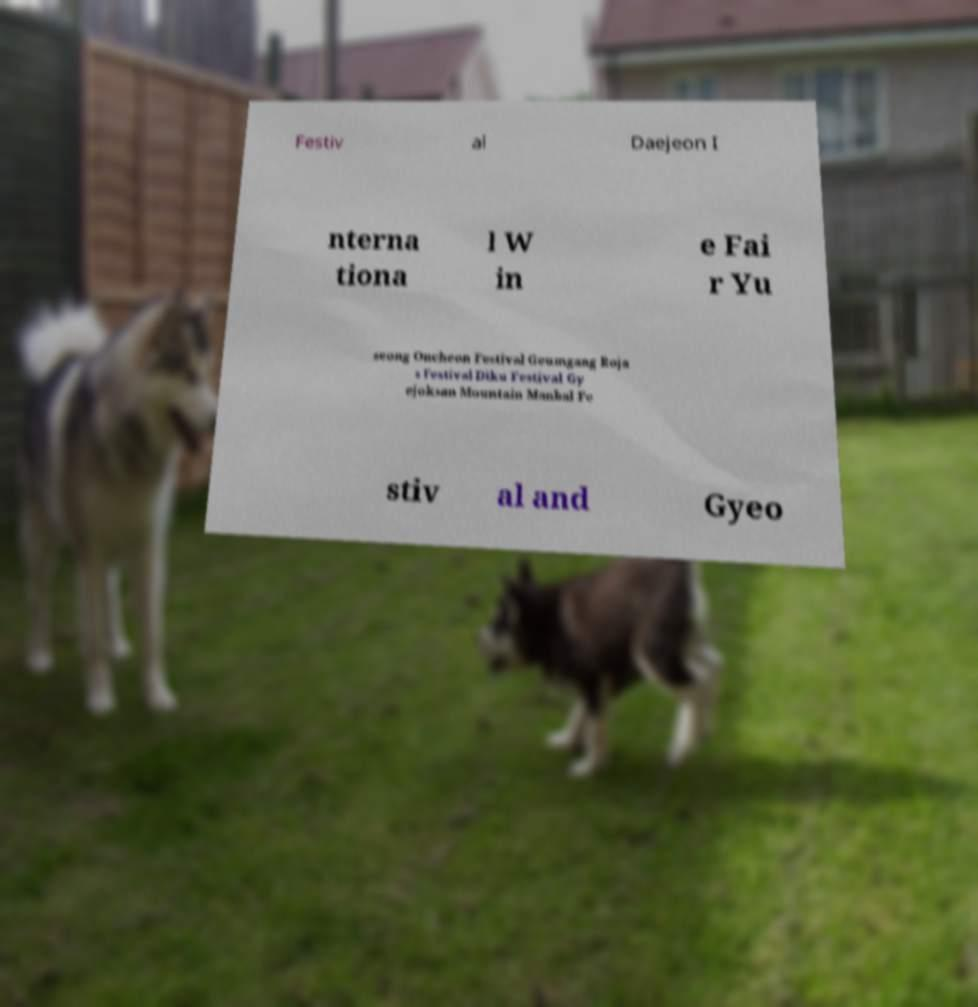Could you assist in decoding the text presented in this image and type it out clearly? Festiv al Daejeon I nterna tiona l W in e Fai r Yu seong Oncheon Festival Geumgang Roja s Festival Diku Festival Gy ejoksan Mountain Manbal Fe stiv al and Gyeo 